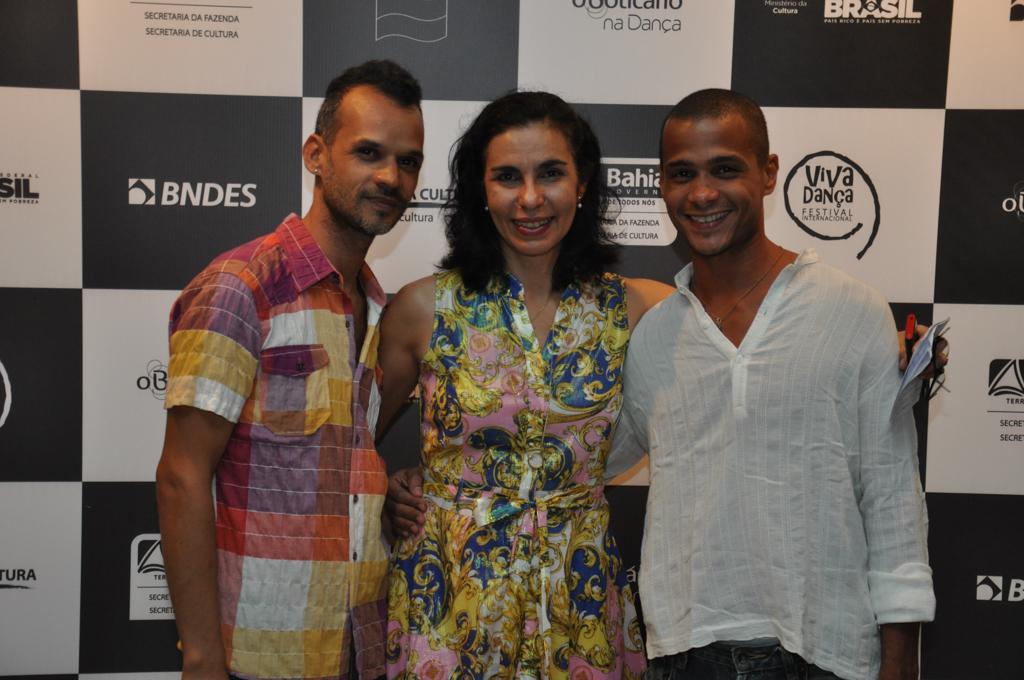Please provide a concise description of this image. In the center of the image we can see person standing on the floor. In the background we can see advertisement. 